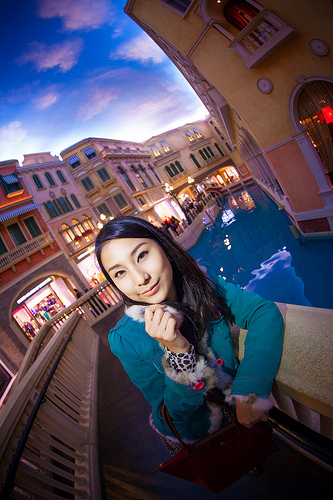<image>
Is there a woman behind the fence? No. The woman is not behind the fence. From this viewpoint, the woman appears to be positioned elsewhere in the scene. 